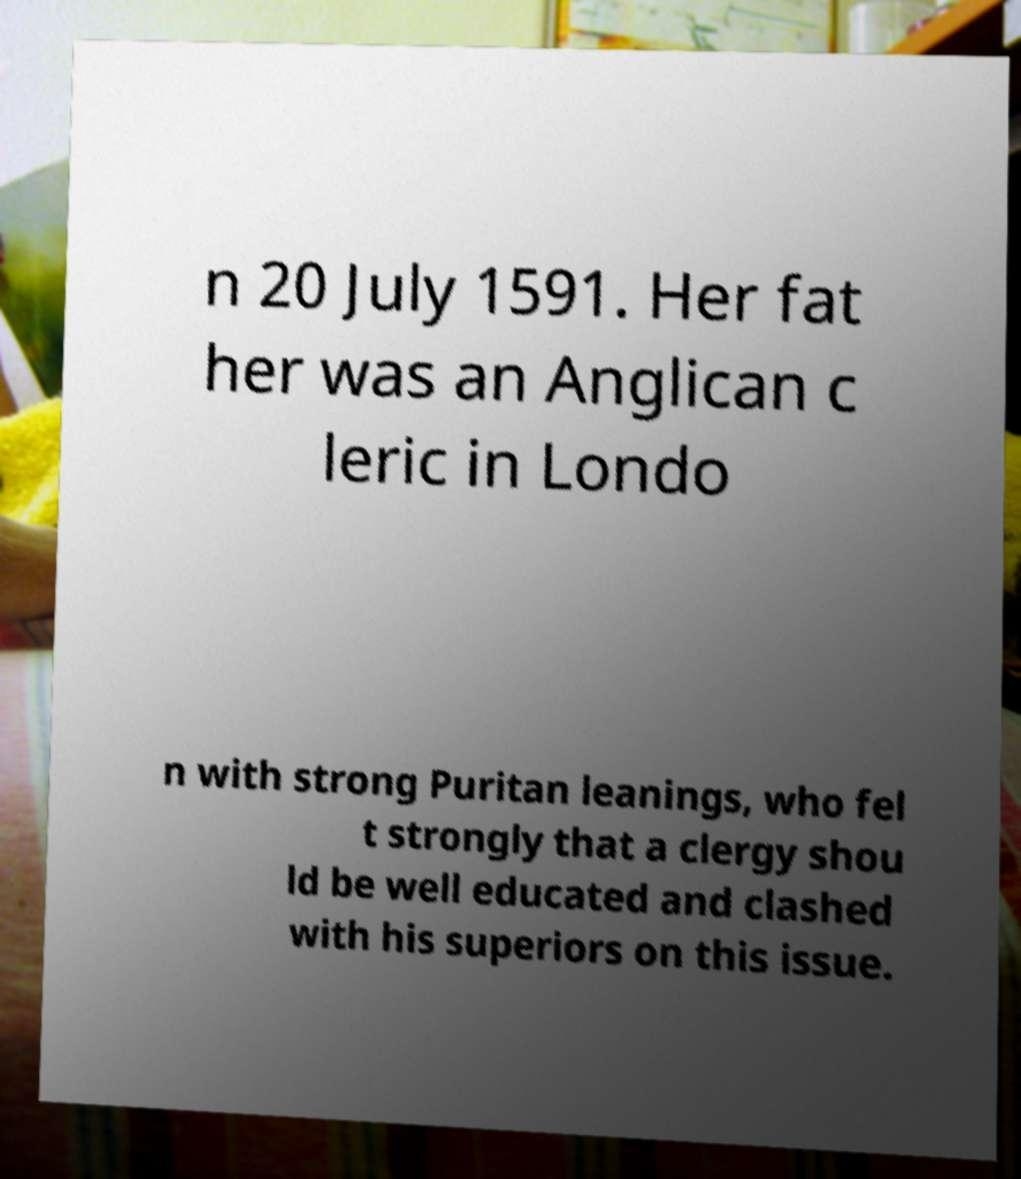Can you accurately transcribe the text from the provided image for me? n 20 July 1591. Her fat her was an Anglican c leric in Londo n with strong Puritan leanings, who fel t strongly that a clergy shou ld be well educated and clashed with his superiors on this issue. 